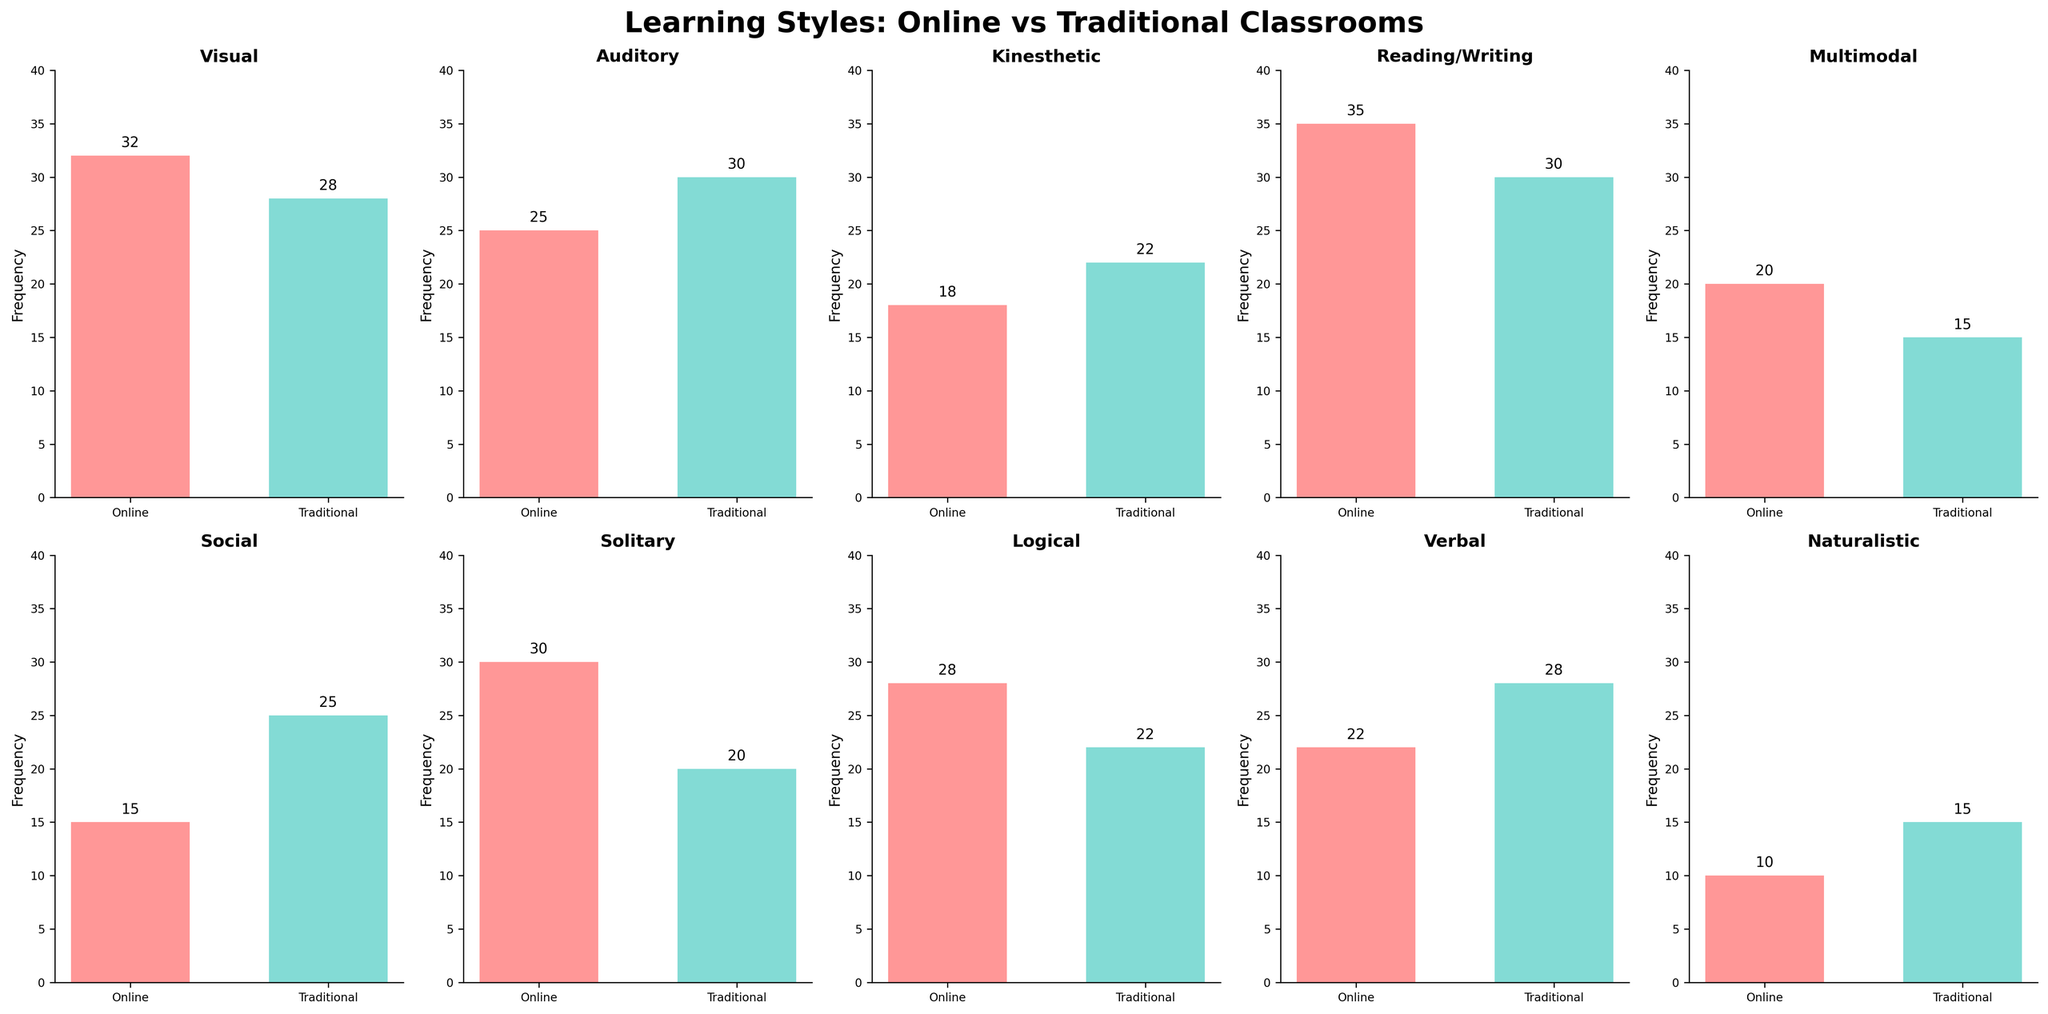What's the title of the figure? The title is prominently displayed at the top of the figure in larger, bold font. It gives an overview of what the figure is depicting.
Answer: Learning Styles: Online vs Traditional Classrooms What is the frequency of students with a Visual learning style in traditional classrooms? Locate the subplot for "Visual" learning style and look at the bar labeled "Traditional." The frequency value is marked just above the bar.
Answer: 28 Which learning style has the highest frequency in online classrooms? Look at all the subplots and identify the bar with the highest value in the "Online" category.
Answer: Reading/Writing How many learning styles have a higher frequency in online classrooms compared to traditional classrooms? Compare the height of the bars for "Online" and "Traditional" across all subplots and count how many of the "Online" bars are taller.
Answer: 6 What's the total frequency of Kinesthetic and Solitary learning styles in traditional classrooms? Locate the subplots for "Kinesthetic" and "Solitary", check their "Traditional" bars, and sum their values: 22 (Kinesthetic) + 20 (Solitary)
Answer: 42 Compare the frequency of Auditory learners in online vs traditional classrooms. Which one is greater? Locate the "Auditory" subplot and compare the heights of the "Online" and "Traditional" bars.
Answer: Traditional Among students with a Social learning style, by how much is the frequency higher in traditional classrooms compared to online classrooms? Locate the "Social" subplot and find the difference between the "Traditional" and "Online" bars: 25 (Traditional) - 15 (Online).
Answer: 10 What's the average frequency of Verbal learners across both classroom types? Sum the frequencies for Verbal learners in both classroom types and divide by 2: (22 + 28) / 2.
Answer: 25 